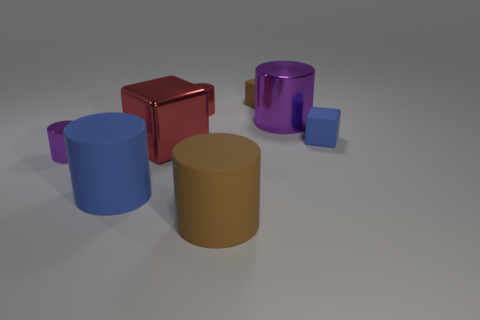Do the purple thing to the left of the blue rubber cylinder and the blue rubber block have the same size?
Offer a terse response. Yes. Is the number of big purple cylinders behind the small red shiny object less than the number of large red things that are to the left of the brown block?
Offer a terse response. Yes. Is the metal cube the same color as the large shiny cylinder?
Provide a short and direct response. No. Are there fewer blue rubber blocks left of the small blue matte cube than green spheres?
Your response must be concise. No. What is the material of the small object that is the same color as the large cube?
Offer a very short reply. Metal. Is the material of the small blue thing the same as the big block?
Provide a short and direct response. No. How many blocks are the same material as the big blue cylinder?
Make the answer very short. 2. What is the color of the block that is the same material as the big purple cylinder?
Your answer should be compact. Red. The small purple object has what shape?
Ensure brevity in your answer.  Cylinder. What is the material of the purple cylinder behind the tiny purple object?
Provide a short and direct response. Metal. 